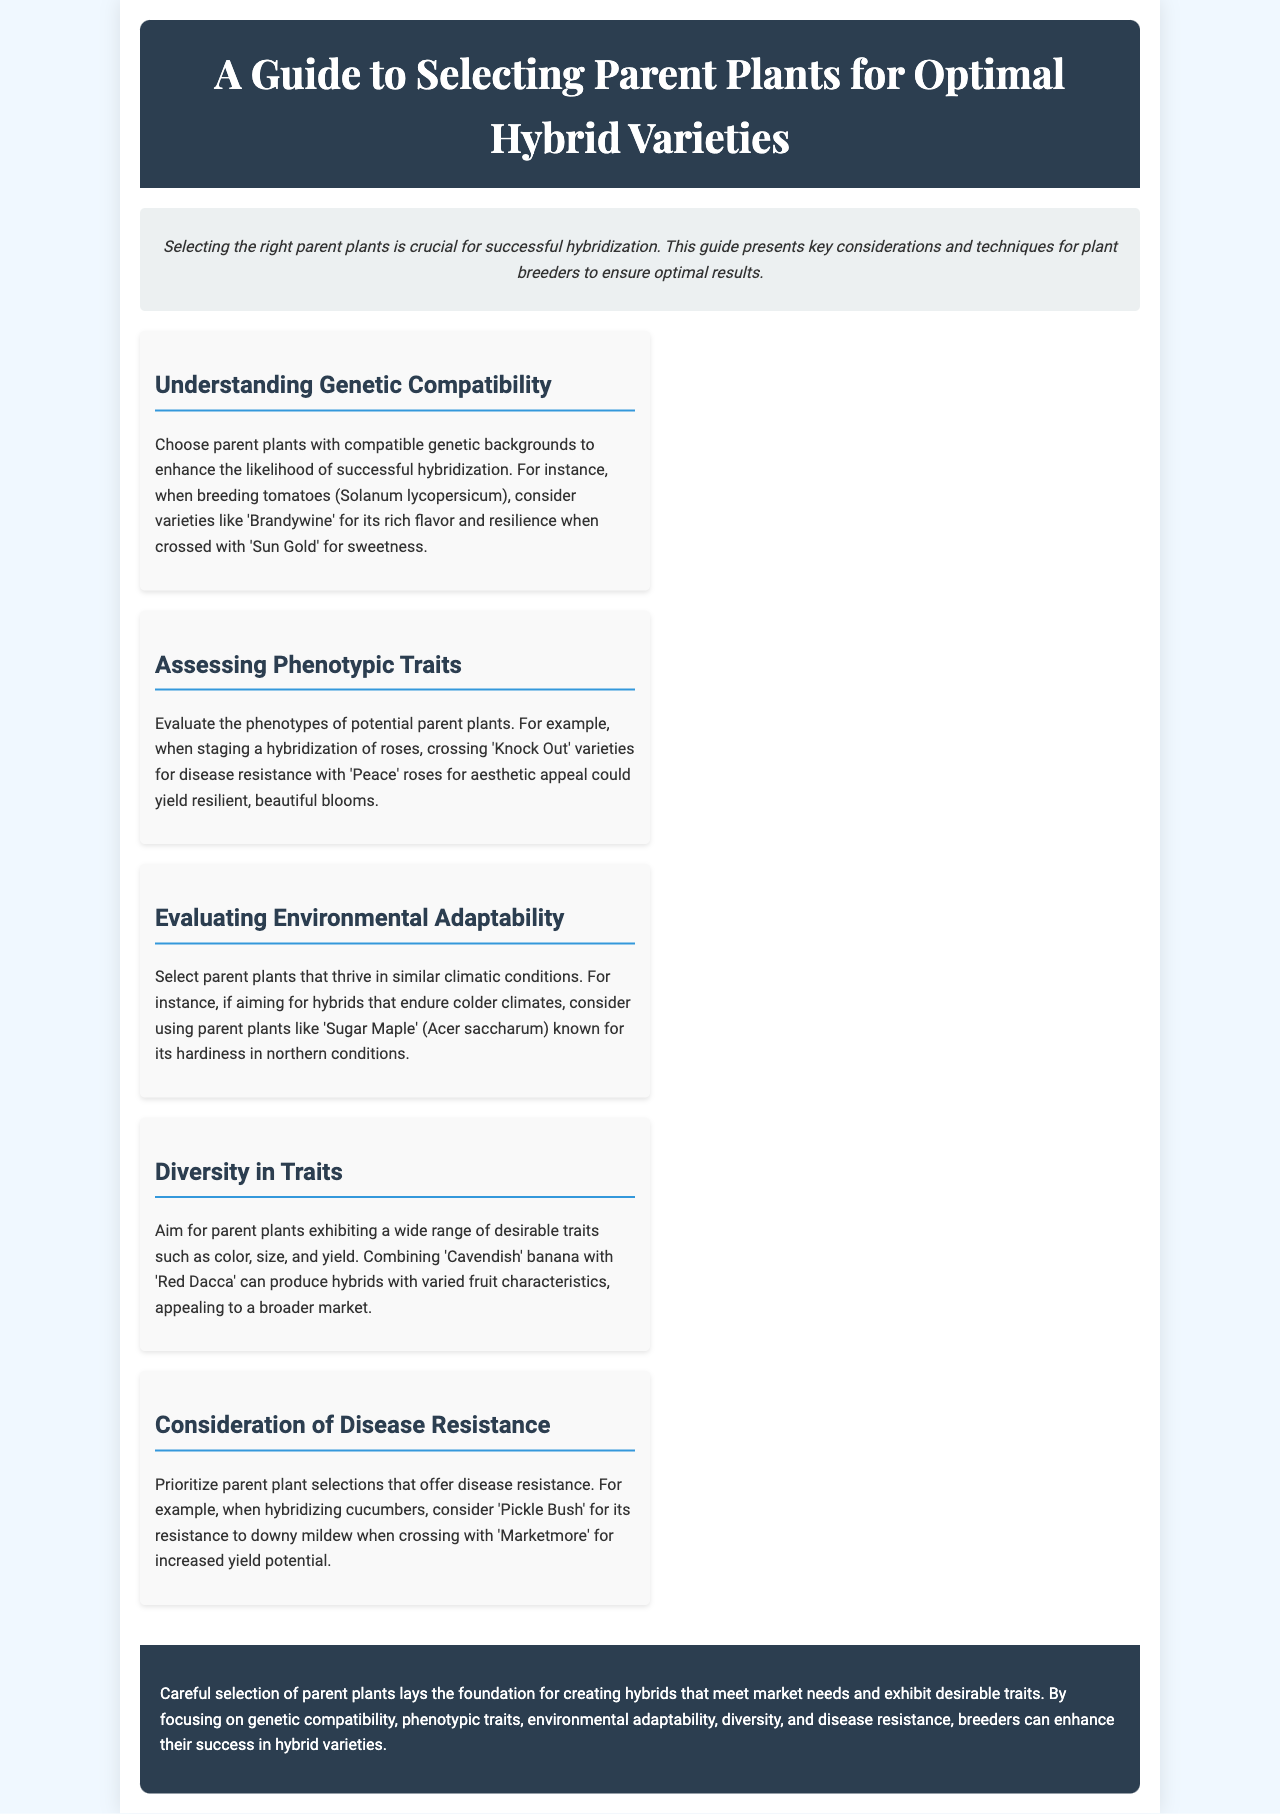What is the main focus of the guide? The guide emphasizes key considerations and techniques for plant breeders to ensure optimal hybrid results.
Answer: Selecting parent plants Which variety is mentioned for its disease resistance in roses? The document discusses 'Knock Out' roses for their disease resistance in the context of hybridization.
Answer: Knock Out How should parent plants be chosen according to genetic compatibility? The guide advises selecting parent plants with compatible genetic backgrounds to enhance hybridization success.
Answer: Compatible genetic backgrounds Which tree is suggested for hybrids that endure colder climates? 'Sugar Maple' (Acer saccharum) is highlighted for its hardiness in northern conditions.
Answer: Sugar Maple What is a benefit of choosing parent plants with diverse traits? The document states that diversity in traits allows for broader market appeal with varied fruit characteristics.
Answer: Broader market appeal What is the ultimate goal of careful selection of parent plants? The goal is to create hybrids that meet market needs and exhibit desirable traits.
Answer: Meet market needs How many sections are in the content area of the brochure? There are five distinct sections presented in the content area of the document.
Answer: Five What type of plants does the guide recommend for environmental adaptability? The guide advises selecting parent plants that thrive in similar climatic conditions.
Answer: Similar climatic conditions 